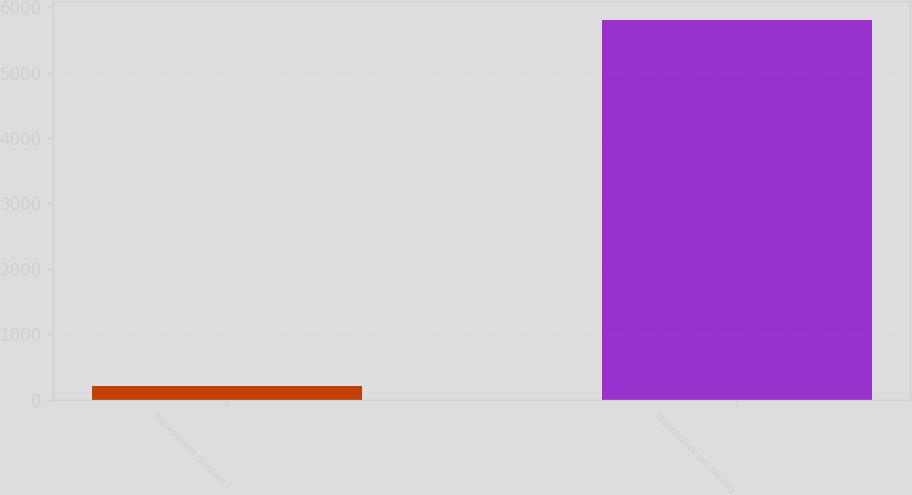Convert chart. <chart><loc_0><loc_0><loc_500><loc_500><bar_chart><fcel>Management revenues<fcel>Maintenance and security<nl><fcel>212<fcel>5805<nl></chart> 